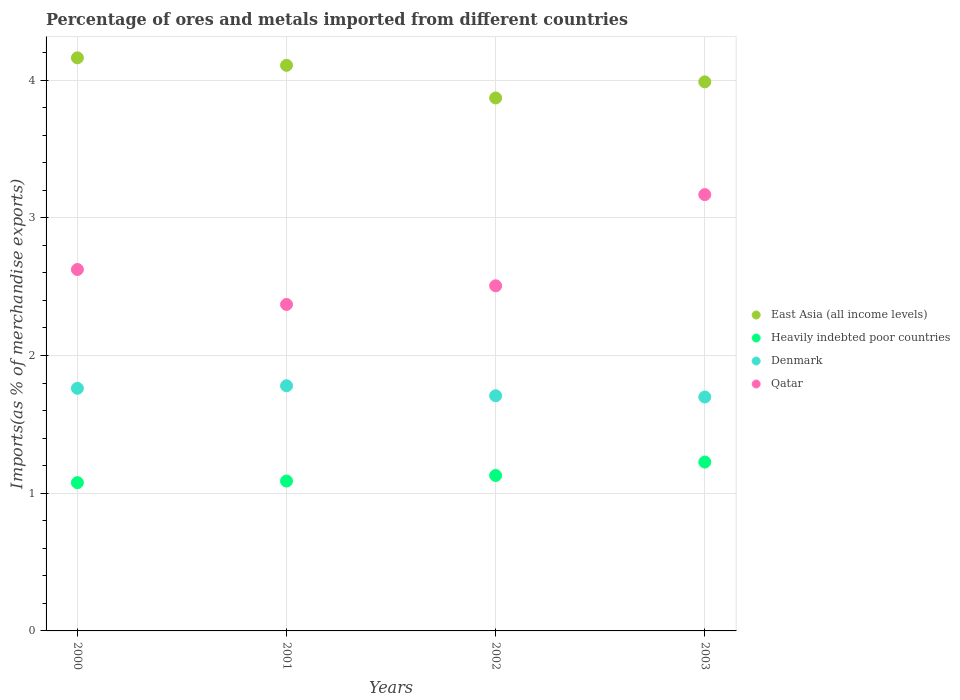Is the number of dotlines equal to the number of legend labels?
Give a very brief answer. Yes. What is the percentage of imports to different countries in Qatar in 2002?
Provide a short and direct response. 2.51. Across all years, what is the maximum percentage of imports to different countries in Denmark?
Ensure brevity in your answer.  1.78. Across all years, what is the minimum percentage of imports to different countries in Denmark?
Provide a succinct answer. 1.7. In which year was the percentage of imports to different countries in Denmark minimum?
Provide a succinct answer. 2003. What is the total percentage of imports to different countries in Heavily indebted poor countries in the graph?
Your response must be concise. 4.52. What is the difference between the percentage of imports to different countries in Heavily indebted poor countries in 2001 and that in 2002?
Ensure brevity in your answer.  -0.04. What is the difference between the percentage of imports to different countries in Heavily indebted poor countries in 2001 and the percentage of imports to different countries in East Asia (all income levels) in 2000?
Offer a terse response. -3.07. What is the average percentage of imports to different countries in Qatar per year?
Offer a terse response. 2.67. In the year 2000, what is the difference between the percentage of imports to different countries in Denmark and percentage of imports to different countries in Heavily indebted poor countries?
Provide a succinct answer. 0.69. What is the ratio of the percentage of imports to different countries in Denmark in 2000 to that in 2002?
Make the answer very short. 1.03. What is the difference between the highest and the second highest percentage of imports to different countries in Heavily indebted poor countries?
Provide a succinct answer. 0.1. What is the difference between the highest and the lowest percentage of imports to different countries in Denmark?
Give a very brief answer. 0.08. In how many years, is the percentage of imports to different countries in Qatar greater than the average percentage of imports to different countries in Qatar taken over all years?
Give a very brief answer. 1. Is the sum of the percentage of imports to different countries in Denmark in 2002 and 2003 greater than the maximum percentage of imports to different countries in Heavily indebted poor countries across all years?
Offer a terse response. Yes. Is it the case that in every year, the sum of the percentage of imports to different countries in Qatar and percentage of imports to different countries in East Asia (all income levels)  is greater than the percentage of imports to different countries in Heavily indebted poor countries?
Provide a short and direct response. Yes. Is the percentage of imports to different countries in Qatar strictly greater than the percentage of imports to different countries in East Asia (all income levels) over the years?
Provide a short and direct response. No. Is the percentage of imports to different countries in Qatar strictly less than the percentage of imports to different countries in Denmark over the years?
Offer a very short reply. No. How many dotlines are there?
Ensure brevity in your answer.  4. Does the graph contain any zero values?
Keep it short and to the point. No. Where does the legend appear in the graph?
Your response must be concise. Center right. What is the title of the graph?
Keep it short and to the point. Percentage of ores and metals imported from different countries. What is the label or title of the Y-axis?
Ensure brevity in your answer.  Imports(as % of merchandise exports). What is the Imports(as % of merchandise exports) in East Asia (all income levels) in 2000?
Your answer should be very brief. 4.16. What is the Imports(as % of merchandise exports) of Heavily indebted poor countries in 2000?
Provide a short and direct response. 1.08. What is the Imports(as % of merchandise exports) of Denmark in 2000?
Offer a terse response. 1.76. What is the Imports(as % of merchandise exports) of Qatar in 2000?
Give a very brief answer. 2.62. What is the Imports(as % of merchandise exports) in East Asia (all income levels) in 2001?
Make the answer very short. 4.11. What is the Imports(as % of merchandise exports) of Heavily indebted poor countries in 2001?
Your response must be concise. 1.09. What is the Imports(as % of merchandise exports) of Denmark in 2001?
Keep it short and to the point. 1.78. What is the Imports(as % of merchandise exports) of Qatar in 2001?
Make the answer very short. 2.37. What is the Imports(as % of merchandise exports) of East Asia (all income levels) in 2002?
Give a very brief answer. 3.87. What is the Imports(as % of merchandise exports) of Heavily indebted poor countries in 2002?
Give a very brief answer. 1.13. What is the Imports(as % of merchandise exports) in Denmark in 2002?
Provide a succinct answer. 1.71. What is the Imports(as % of merchandise exports) in Qatar in 2002?
Give a very brief answer. 2.51. What is the Imports(as % of merchandise exports) of East Asia (all income levels) in 2003?
Keep it short and to the point. 3.99. What is the Imports(as % of merchandise exports) of Heavily indebted poor countries in 2003?
Ensure brevity in your answer.  1.23. What is the Imports(as % of merchandise exports) of Denmark in 2003?
Ensure brevity in your answer.  1.7. What is the Imports(as % of merchandise exports) in Qatar in 2003?
Your answer should be compact. 3.17. Across all years, what is the maximum Imports(as % of merchandise exports) of East Asia (all income levels)?
Offer a very short reply. 4.16. Across all years, what is the maximum Imports(as % of merchandise exports) of Heavily indebted poor countries?
Your response must be concise. 1.23. Across all years, what is the maximum Imports(as % of merchandise exports) of Denmark?
Your answer should be compact. 1.78. Across all years, what is the maximum Imports(as % of merchandise exports) of Qatar?
Offer a terse response. 3.17. Across all years, what is the minimum Imports(as % of merchandise exports) of East Asia (all income levels)?
Ensure brevity in your answer.  3.87. Across all years, what is the minimum Imports(as % of merchandise exports) of Heavily indebted poor countries?
Give a very brief answer. 1.08. Across all years, what is the minimum Imports(as % of merchandise exports) in Denmark?
Provide a succinct answer. 1.7. Across all years, what is the minimum Imports(as % of merchandise exports) in Qatar?
Keep it short and to the point. 2.37. What is the total Imports(as % of merchandise exports) of East Asia (all income levels) in the graph?
Your response must be concise. 16.13. What is the total Imports(as % of merchandise exports) of Heavily indebted poor countries in the graph?
Your answer should be very brief. 4.52. What is the total Imports(as % of merchandise exports) in Denmark in the graph?
Your answer should be compact. 6.95. What is the total Imports(as % of merchandise exports) of Qatar in the graph?
Give a very brief answer. 10.67. What is the difference between the Imports(as % of merchandise exports) of East Asia (all income levels) in 2000 and that in 2001?
Make the answer very short. 0.05. What is the difference between the Imports(as % of merchandise exports) in Heavily indebted poor countries in 2000 and that in 2001?
Provide a succinct answer. -0.01. What is the difference between the Imports(as % of merchandise exports) of Denmark in 2000 and that in 2001?
Offer a very short reply. -0.02. What is the difference between the Imports(as % of merchandise exports) of Qatar in 2000 and that in 2001?
Provide a short and direct response. 0.25. What is the difference between the Imports(as % of merchandise exports) of East Asia (all income levels) in 2000 and that in 2002?
Provide a short and direct response. 0.29. What is the difference between the Imports(as % of merchandise exports) of Heavily indebted poor countries in 2000 and that in 2002?
Offer a very short reply. -0.05. What is the difference between the Imports(as % of merchandise exports) of Denmark in 2000 and that in 2002?
Provide a short and direct response. 0.05. What is the difference between the Imports(as % of merchandise exports) of Qatar in 2000 and that in 2002?
Give a very brief answer. 0.12. What is the difference between the Imports(as % of merchandise exports) of East Asia (all income levels) in 2000 and that in 2003?
Offer a very short reply. 0.17. What is the difference between the Imports(as % of merchandise exports) of Heavily indebted poor countries in 2000 and that in 2003?
Offer a terse response. -0.15. What is the difference between the Imports(as % of merchandise exports) in Denmark in 2000 and that in 2003?
Your response must be concise. 0.06. What is the difference between the Imports(as % of merchandise exports) in Qatar in 2000 and that in 2003?
Your answer should be very brief. -0.54. What is the difference between the Imports(as % of merchandise exports) in East Asia (all income levels) in 2001 and that in 2002?
Your answer should be very brief. 0.24. What is the difference between the Imports(as % of merchandise exports) of Heavily indebted poor countries in 2001 and that in 2002?
Offer a terse response. -0.04. What is the difference between the Imports(as % of merchandise exports) in Denmark in 2001 and that in 2002?
Your answer should be very brief. 0.07. What is the difference between the Imports(as % of merchandise exports) of Qatar in 2001 and that in 2002?
Give a very brief answer. -0.14. What is the difference between the Imports(as % of merchandise exports) of East Asia (all income levels) in 2001 and that in 2003?
Keep it short and to the point. 0.12. What is the difference between the Imports(as % of merchandise exports) in Heavily indebted poor countries in 2001 and that in 2003?
Your response must be concise. -0.14. What is the difference between the Imports(as % of merchandise exports) in Denmark in 2001 and that in 2003?
Your answer should be compact. 0.08. What is the difference between the Imports(as % of merchandise exports) in Qatar in 2001 and that in 2003?
Offer a very short reply. -0.8. What is the difference between the Imports(as % of merchandise exports) of East Asia (all income levels) in 2002 and that in 2003?
Provide a short and direct response. -0.12. What is the difference between the Imports(as % of merchandise exports) of Heavily indebted poor countries in 2002 and that in 2003?
Make the answer very short. -0.1. What is the difference between the Imports(as % of merchandise exports) in Denmark in 2002 and that in 2003?
Ensure brevity in your answer.  0.01. What is the difference between the Imports(as % of merchandise exports) in Qatar in 2002 and that in 2003?
Provide a short and direct response. -0.66. What is the difference between the Imports(as % of merchandise exports) of East Asia (all income levels) in 2000 and the Imports(as % of merchandise exports) of Heavily indebted poor countries in 2001?
Give a very brief answer. 3.07. What is the difference between the Imports(as % of merchandise exports) of East Asia (all income levels) in 2000 and the Imports(as % of merchandise exports) of Denmark in 2001?
Make the answer very short. 2.38. What is the difference between the Imports(as % of merchandise exports) of East Asia (all income levels) in 2000 and the Imports(as % of merchandise exports) of Qatar in 2001?
Your answer should be compact. 1.79. What is the difference between the Imports(as % of merchandise exports) in Heavily indebted poor countries in 2000 and the Imports(as % of merchandise exports) in Denmark in 2001?
Keep it short and to the point. -0.7. What is the difference between the Imports(as % of merchandise exports) of Heavily indebted poor countries in 2000 and the Imports(as % of merchandise exports) of Qatar in 2001?
Offer a very short reply. -1.29. What is the difference between the Imports(as % of merchandise exports) in Denmark in 2000 and the Imports(as % of merchandise exports) in Qatar in 2001?
Offer a terse response. -0.61. What is the difference between the Imports(as % of merchandise exports) in East Asia (all income levels) in 2000 and the Imports(as % of merchandise exports) in Heavily indebted poor countries in 2002?
Keep it short and to the point. 3.03. What is the difference between the Imports(as % of merchandise exports) of East Asia (all income levels) in 2000 and the Imports(as % of merchandise exports) of Denmark in 2002?
Your answer should be very brief. 2.45. What is the difference between the Imports(as % of merchandise exports) of East Asia (all income levels) in 2000 and the Imports(as % of merchandise exports) of Qatar in 2002?
Provide a succinct answer. 1.66. What is the difference between the Imports(as % of merchandise exports) of Heavily indebted poor countries in 2000 and the Imports(as % of merchandise exports) of Denmark in 2002?
Your answer should be very brief. -0.63. What is the difference between the Imports(as % of merchandise exports) of Heavily indebted poor countries in 2000 and the Imports(as % of merchandise exports) of Qatar in 2002?
Keep it short and to the point. -1.43. What is the difference between the Imports(as % of merchandise exports) of Denmark in 2000 and the Imports(as % of merchandise exports) of Qatar in 2002?
Your answer should be compact. -0.74. What is the difference between the Imports(as % of merchandise exports) in East Asia (all income levels) in 2000 and the Imports(as % of merchandise exports) in Heavily indebted poor countries in 2003?
Give a very brief answer. 2.94. What is the difference between the Imports(as % of merchandise exports) in East Asia (all income levels) in 2000 and the Imports(as % of merchandise exports) in Denmark in 2003?
Your answer should be very brief. 2.46. What is the difference between the Imports(as % of merchandise exports) in Heavily indebted poor countries in 2000 and the Imports(as % of merchandise exports) in Denmark in 2003?
Make the answer very short. -0.62. What is the difference between the Imports(as % of merchandise exports) of Heavily indebted poor countries in 2000 and the Imports(as % of merchandise exports) of Qatar in 2003?
Provide a short and direct response. -2.09. What is the difference between the Imports(as % of merchandise exports) in Denmark in 2000 and the Imports(as % of merchandise exports) in Qatar in 2003?
Offer a terse response. -1.41. What is the difference between the Imports(as % of merchandise exports) of East Asia (all income levels) in 2001 and the Imports(as % of merchandise exports) of Heavily indebted poor countries in 2002?
Ensure brevity in your answer.  2.98. What is the difference between the Imports(as % of merchandise exports) in East Asia (all income levels) in 2001 and the Imports(as % of merchandise exports) in Denmark in 2002?
Your answer should be very brief. 2.4. What is the difference between the Imports(as % of merchandise exports) in East Asia (all income levels) in 2001 and the Imports(as % of merchandise exports) in Qatar in 2002?
Your response must be concise. 1.6. What is the difference between the Imports(as % of merchandise exports) in Heavily indebted poor countries in 2001 and the Imports(as % of merchandise exports) in Denmark in 2002?
Offer a very short reply. -0.62. What is the difference between the Imports(as % of merchandise exports) in Heavily indebted poor countries in 2001 and the Imports(as % of merchandise exports) in Qatar in 2002?
Offer a very short reply. -1.42. What is the difference between the Imports(as % of merchandise exports) of Denmark in 2001 and the Imports(as % of merchandise exports) of Qatar in 2002?
Make the answer very short. -0.73. What is the difference between the Imports(as % of merchandise exports) in East Asia (all income levels) in 2001 and the Imports(as % of merchandise exports) in Heavily indebted poor countries in 2003?
Make the answer very short. 2.88. What is the difference between the Imports(as % of merchandise exports) of East Asia (all income levels) in 2001 and the Imports(as % of merchandise exports) of Denmark in 2003?
Your answer should be very brief. 2.41. What is the difference between the Imports(as % of merchandise exports) in East Asia (all income levels) in 2001 and the Imports(as % of merchandise exports) in Qatar in 2003?
Make the answer very short. 0.94. What is the difference between the Imports(as % of merchandise exports) in Heavily indebted poor countries in 2001 and the Imports(as % of merchandise exports) in Denmark in 2003?
Give a very brief answer. -0.61. What is the difference between the Imports(as % of merchandise exports) in Heavily indebted poor countries in 2001 and the Imports(as % of merchandise exports) in Qatar in 2003?
Make the answer very short. -2.08. What is the difference between the Imports(as % of merchandise exports) of Denmark in 2001 and the Imports(as % of merchandise exports) of Qatar in 2003?
Give a very brief answer. -1.39. What is the difference between the Imports(as % of merchandise exports) of East Asia (all income levels) in 2002 and the Imports(as % of merchandise exports) of Heavily indebted poor countries in 2003?
Your answer should be very brief. 2.64. What is the difference between the Imports(as % of merchandise exports) of East Asia (all income levels) in 2002 and the Imports(as % of merchandise exports) of Denmark in 2003?
Provide a short and direct response. 2.17. What is the difference between the Imports(as % of merchandise exports) of East Asia (all income levels) in 2002 and the Imports(as % of merchandise exports) of Qatar in 2003?
Your answer should be compact. 0.7. What is the difference between the Imports(as % of merchandise exports) in Heavily indebted poor countries in 2002 and the Imports(as % of merchandise exports) in Denmark in 2003?
Provide a short and direct response. -0.57. What is the difference between the Imports(as % of merchandise exports) of Heavily indebted poor countries in 2002 and the Imports(as % of merchandise exports) of Qatar in 2003?
Provide a succinct answer. -2.04. What is the difference between the Imports(as % of merchandise exports) of Denmark in 2002 and the Imports(as % of merchandise exports) of Qatar in 2003?
Offer a terse response. -1.46. What is the average Imports(as % of merchandise exports) in East Asia (all income levels) per year?
Offer a very short reply. 4.03. What is the average Imports(as % of merchandise exports) of Heavily indebted poor countries per year?
Give a very brief answer. 1.13. What is the average Imports(as % of merchandise exports) of Denmark per year?
Ensure brevity in your answer.  1.74. What is the average Imports(as % of merchandise exports) of Qatar per year?
Your answer should be very brief. 2.67. In the year 2000, what is the difference between the Imports(as % of merchandise exports) in East Asia (all income levels) and Imports(as % of merchandise exports) in Heavily indebted poor countries?
Keep it short and to the point. 3.09. In the year 2000, what is the difference between the Imports(as % of merchandise exports) in East Asia (all income levels) and Imports(as % of merchandise exports) in Denmark?
Your response must be concise. 2.4. In the year 2000, what is the difference between the Imports(as % of merchandise exports) in East Asia (all income levels) and Imports(as % of merchandise exports) in Qatar?
Make the answer very short. 1.54. In the year 2000, what is the difference between the Imports(as % of merchandise exports) in Heavily indebted poor countries and Imports(as % of merchandise exports) in Denmark?
Your answer should be very brief. -0.69. In the year 2000, what is the difference between the Imports(as % of merchandise exports) of Heavily indebted poor countries and Imports(as % of merchandise exports) of Qatar?
Offer a very short reply. -1.55. In the year 2000, what is the difference between the Imports(as % of merchandise exports) of Denmark and Imports(as % of merchandise exports) of Qatar?
Provide a succinct answer. -0.86. In the year 2001, what is the difference between the Imports(as % of merchandise exports) of East Asia (all income levels) and Imports(as % of merchandise exports) of Heavily indebted poor countries?
Your answer should be compact. 3.02. In the year 2001, what is the difference between the Imports(as % of merchandise exports) in East Asia (all income levels) and Imports(as % of merchandise exports) in Denmark?
Your answer should be compact. 2.33. In the year 2001, what is the difference between the Imports(as % of merchandise exports) of East Asia (all income levels) and Imports(as % of merchandise exports) of Qatar?
Your response must be concise. 1.74. In the year 2001, what is the difference between the Imports(as % of merchandise exports) in Heavily indebted poor countries and Imports(as % of merchandise exports) in Denmark?
Your response must be concise. -0.69. In the year 2001, what is the difference between the Imports(as % of merchandise exports) of Heavily indebted poor countries and Imports(as % of merchandise exports) of Qatar?
Give a very brief answer. -1.28. In the year 2001, what is the difference between the Imports(as % of merchandise exports) of Denmark and Imports(as % of merchandise exports) of Qatar?
Give a very brief answer. -0.59. In the year 2002, what is the difference between the Imports(as % of merchandise exports) in East Asia (all income levels) and Imports(as % of merchandise exports) in Heavily indebted poor countries?
Provide a succinct answer. 2.74. In the year 2002, what is the difference between the Imports(as % of merchandise exports) of East Asia (all income levels) and Imports(as % of merchandise exports) of Denmark?
Your answer should be compact. 2.16. In the year 2002, what is the difference between the Imports(as % of merchandise exports) in East Asia (all income levels) and Imports(as % of merchandise exports) in Qatar?
Provide a succinct answer. 1.36. In the year 2002, what is the difference between the Imports(as % of merchandise exports) in Heavily indebted poor countries and Imports(as % of merchandise exports) in Denmark?
Your answer should be very brief. -0.58. In the year 2002, what is the difference between the Imports(as % of merchandise exports) in Heavily indebted poor countries and Imports(as % of merchandise exports) in Qatar?
Make the answer very short. -1.38. In the year 2002, what is the difference between the Imports(as % of merchandise exports) in Denmark and Imports(as % of merchandise exports) in Qatar?
Offer a very short reply. -0.8. In the year 2003, what is the difference between the Imports(as % of merchandise exports) of East Asia (all income levels) and Imports(as % of merchandise exports) of Heavily indebted poor countries?
Ensure brevity in your answer.  2.76. In the year 2003, what is the difference between the Imports(as % of merchandise exports) in East Asia (all income levels) and Imports(as % of merchandise exports) in Denmark?
Provide a short and direct response. 2.29. In the year 2003, what is the difference between the Imports(as % of merchandise exports) of East Asia (all income levels) and Imports(as % of merchandise exports) of Qatar?
Give a very brief answer. 0.82. In the year 2003, what is the difference between the Imports(as % of merchandise exports) of Heavily indebted poor countries and Imports(as % of merchandise exports) of Denmark?
Make the answer very short. -0.47. In the year 2003, what is the difference between the Imports(as % of merchandise exports) of Heavily indebted poor countries and Imports(as % of merchandise exports) of Qatar?
Your response must be concise. -1.94. In the year 2003, what is the difference between the Imports(as % of merchandise exports) of Denmark and Imports(as % of merchandise exports) of Qatar?
Ensure brevity in your answer.  -1.47. What is the ratio of the Imports(as % of merchandise exports) of East Asia (all income levels) in 2000 to that in 2001?
Provide a short and direct response. 1.01. What is the ratio of the Imports(as % of merchandise exports) of Heavily indebted poor countries in 2000 to that in 2001?
Make the answer very short. 0.99. What is the ratio of the Imports(as % of merchandise exports) of Denmark in 2000 to that in 2001?
Provide a succinct answer. 0.99. What is the ratio of the Imports(as % of merchandise exports) in Qatar in 2000 to that in 2001?
Make the answer very short. 1.11. What is the ratio of the Imports(as % of merchandise exports) of East Asia (all income levels) in 2000 to that in 2002?
Offer a terse response. 1.08. What is the ratio of the Imports(as % of merchandise exports) of Heavily indebted poor countries in 2000 to that in 2002?
Offer a terse response. 0.95. What is the ratio of the Imports(as % of merchandise exports) in Denmark in 2000 to that in 2002?
Your answer should be very brief. 1.03. What is the ratio of the Imports(as % of merchandise exports) of Qatar in 2000 to that in 2002?
Give a very brief answer. 1.05. What is the ratio of the Imports(as % of merchandise exports) in East Asia (all income levels) in 2000 to that in 2003?
Give a very brief answer. 1.04. What is the ratio of the Imports(as % of merchandise exports) of Heavily indebted poor countries in 2000 to that in 2003?
Make the answer very short. 0.88. What is the ratio of the Imports(as % of merchandise exports) of Denmark in 2000 to that in 2003?
Your answer should be compact. 1.04. What is the ratio of the Imports(as % of merchandise exports) of Qatar in 2000 to that in 2003?
Offer a very short reply. 0.83. What is the ratio of the Imports(as % of merchandise exports) of East Asia (all income levels) in 2001 to that in 2002?
Provide a succinct answer. 1.06. What is the ratio of the Imports(as % of merchandise exports) of Heavily indebted poor countries in 2001 to that in 2002?
Keep it short and to the point. 0.96. What is the ratio of the Imports(as % of merchandise exports) in Denmark in 2001 to that in 2002?
Keep it short and to the point. 1.04. What is the ratio of the Imports(as % of merchandise exports) in Qatar in 2001 to that in 2002?
Give a very brief answer. 0.95. What is the ratio of the Imports(as % of merchandise exports) in East Asia (all income levels) in 2001 to that in 2003?
Keep it short and to the point. 1.03. What is the ratio of the Imports(as % of merchandise exports) in Heavily indebted poor countries in 2001 to that in 2003?
Your answer should be compact. 0.89. What is the ratio of the Imports(as % of merchandise exports) of Denmark in 2001 to that in 2003?
Your answer should be very brief. 1.05. What is the ratio of the Imports(as % of merchandise exports) of Qatar in 2001 to that in 2003?
Your answer should be very brief. 0.75. What is the ratio of the Imports(as % of merchandise exports) of East Asia (all income levels) in 2002 to that in 2003?
Provide a short and direct response. 0.97. What is the ratio of the Imports(as % of merchandise exports) of Heavily indebted poor countries in 2002 to that in 2003?
Your answer should be compact. 0.92. What is the ratio of the Imports(as % of merchandise exports) in Denmark in 2002 to that in 2003?
Offer a terse response. 1.01. What is the ratio of the Imports(as % of merchandise exports) of Qatar in 2002 to that in 2003?
Provide a succinct answer. 0.79. What is the difference between the highest and the second highest Imports(as % of merchandise exports) of East Asia (all income levels)?
Give a very brief answer. 0.05. What is the difference between the highest and the second highest Imports(as % of merchandise exports) in Heavily indebted poor countries?
Offer a terse response. 0.1. What is the difference between the highest and the second highest Imports(as % of merchandise exports) in Denmark?
Your answer should be very brief. 0.02. What is the difference between the highest and the second highest Imports(as % of merchandise exports) of Qatar?
Offer a very short reply. 0.54. What is the difference between the highest and the lowest Imports(as % of merchandise exports) of East Asia (all income levels)?
Provide a short and direct response. 0.29. What is the difference between the highest and the lowest Imports(as % of merchandise exports) of Heavily indebted poor countries?
Offer a terse response. 0.15. What is the difference between the highest and the lowest Imports(as % of merchandise exports) in Denmark?
Offer a very short reply. 0.08. What is the difference between the highest and the lowest Imports(as % of merchandise exports) in Qatar?
Your response must be concise. 0.8. 